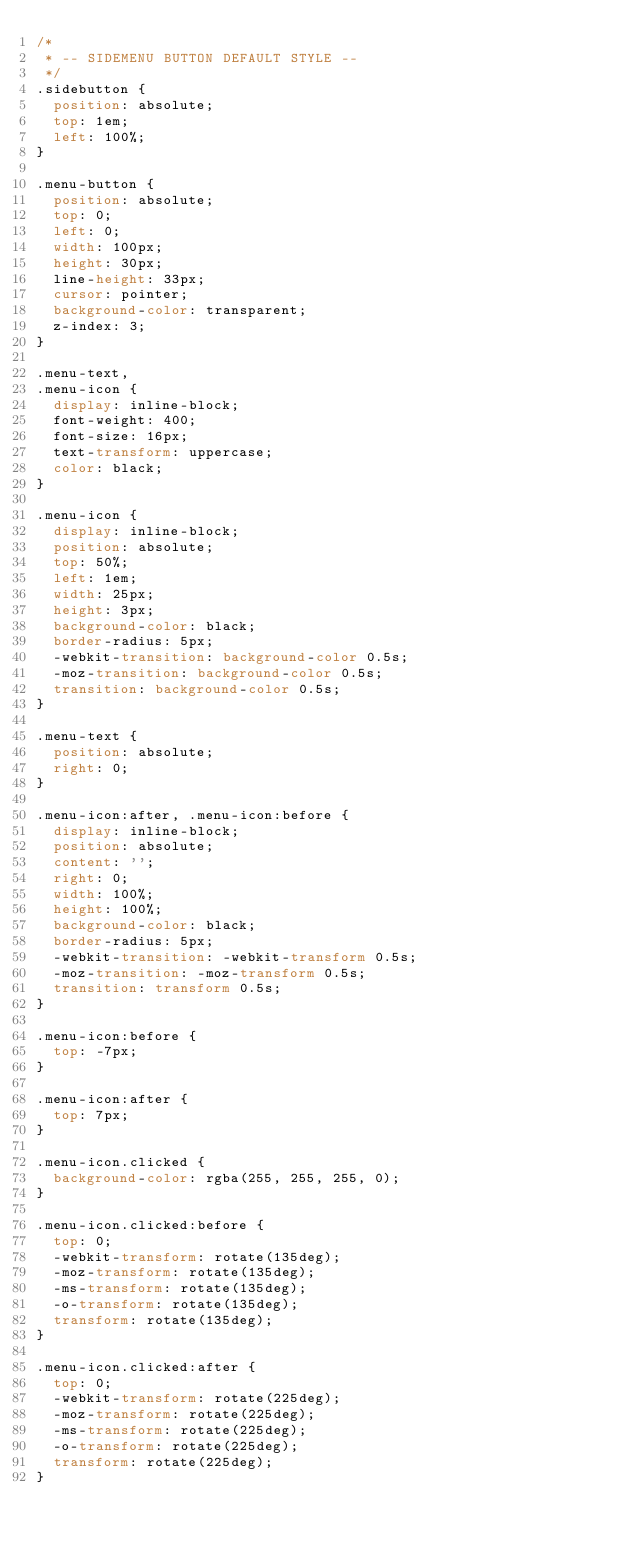<code> <loc_0><loc_0><loc_500><loc_500><_CSS_>/*
 * -- SIDEMENU BUTTON DEFAULT STYLE --
 */
.sidebutton {
  position: absolute;
  top: 1em;
  left: 100%;
}

.menu-button {
  position: absolute;
  top: 0;
  left: 0;
  width: 100px;
  height: 30px;
  line-height: 33px;
  cursor: pointer;
  background-color: transparent;
  z-index: 3;
}

.menu-text,
.menu-icon {
  display: inline-block;
  font-weight: 400;
  font-size: 16px;
  text-transform: uppercase;
  color: black;
}

.menu-icon {
  display: inline-block;
  position: absolute;
  top: 50%;
  left: 1em;
  width: 25px;
  height: 3px;
  background-color: black;
  border-radius: 5px;
  -webkit-transition: background-color 0.5s;
  -moz-transition: background-color 0.5s;
  transition: background-color 0.5s;
}

.menu-text {
  position: absolute;
  right: 0;
}

.menu-icon:after, .menu-icon:before {
  display: inline-block;
  position: absolute;
  content: '';
  right: 0;
  width: 100%;
  height: 100%;
  background-color: black;
  border-radius: 5px;
  -webkit-transition: -webkit-transform 0.5s;
  -moz-transition: -moz-transform 0.5s;
  transition: transform 0.5s;
}

.menu-icon:before {
  top: -7px;
}

.menu-icon:after {
  top: 7px;
}

.menu-icon.clicked {
  background-color: rgba(255, 255, 255, 0);
}

.menu-icon.clicked:before {
  top: 0;
  -webkit-transform: rotate(135deg);
  -moz-transform: rotate(135deg);
  -ms-transform: rotate(135deg);
  -o-transform: rotate(135deg);
  transform: rotate(135deg);
}

.menu-icon.clicked:after {
  top: 0;
  -webkit-transform: rotate(225deg);
  -moz-transform: rotate(225deg);
  -ms-transform: rotate(225deg);
  -o-transform: rotate(225deg);
  transform: rotate(225deg);
}
</code> 